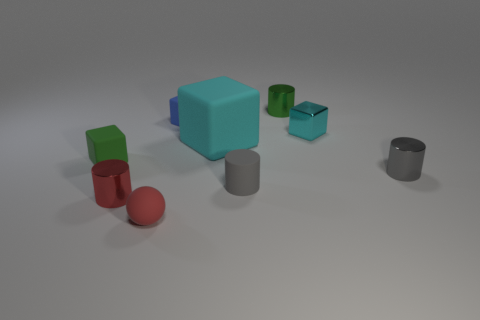Are there any other things that are the same size as the cyan rubber block?
Provide a short and direct response. No. Are there any red objects in front of the matte cylinder?
Keep it short and to the point. Yes. Are there the same number of small red spheres that are to the right of the blue matte object and gray things right of the small cyan shiny block?
Provide a short and direct response. No. Does the green thing to the left of the blue rubber block have the same size as the shiny cylinder that is to the left of the red rubber object?
Provide a short and direct response. Yes. There is a cyan thing in front of the tiny block to the right of the tiny green cylinder that is behind the metal cube; what is its shape?
Offer a terse response. Cube. What size is the shiny object that is the same shape as the blue matte thing?
Ensure brevity in your answer.  Small. There is a small cube that is both on the left side of the metal block and on the right side of the sphere; what is its color?
Your answer should be very brief. Blue. Is the material of the big cube the same as the block right of the large cyan rubber cube?
Offer a very short reply. No. Are there fewer tiny red shiny cylinders behind the small cyan metal block than tiny cyan metallic blocks?
Make the answer very short. Yes. What number of other things are there of the same shape as the big matte object?
Ensure brevity in your answer.  3. 